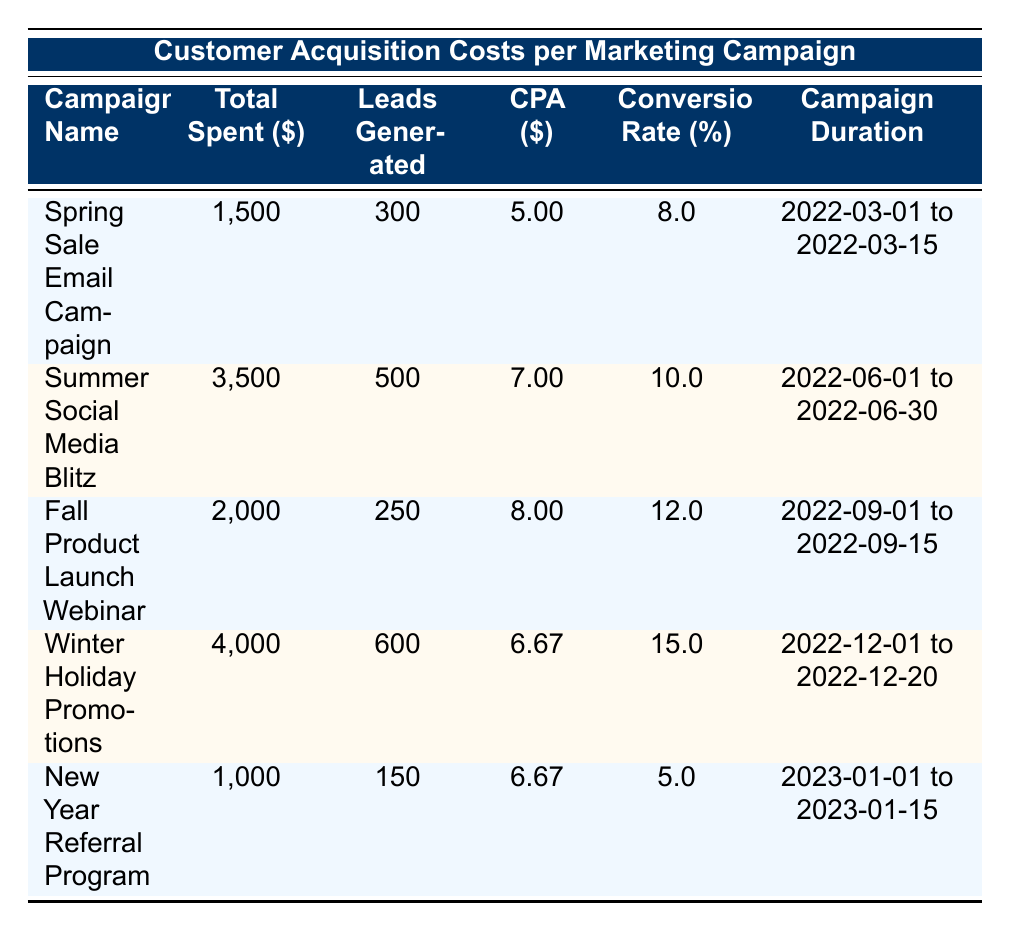What is the total amount spent on the Winter Holiday Promotions campaign? Referring to the table, the total spent for the Winter Holiday Promotions campaign is indicated in the second column under “Total Spent,” which shows $4000.
Answer: 4000 What is the conversion rate for the Summer Social Media Blitz campaign? Looking at the Summer Social Media Blitz campaign row, the conversion rate is listed in the fifth column as 10.0%.
Answer: 10.0 Which campaign had the lowest cost per acquisition? To determine the lowest cost per acquisition (CPA), I compare the CPA values from each row. The Spring Sale Email Campaign has the lowest CPA at $5.00.
Answer: 5.00 What is the total number of leads generated from all campaigns combined? I need to sum the leads generated from each campaign: 300 + 500 + 250 + 600 + 150 = 1800 leads in total.
Answer: 1800 Did the Fall Product Launch Webinar have a higher CPA than the New Year Referral Program? I check the CPA for both campaigns: the Fall Product Launch Webinar is $8.00, and the New Year Referral Program is $6.67. Since $8.00 is greater than $6.67, the statement is true.
Answer: Yes What was the average cost per acquisition across all campaigns? I sum the CPA values from each campaign: 5.00 + 7.00 + 8.00 + 6.67 + 6.67 = 33.34. Since there are 5 campaigns, the average CPA is 33.34 divided by 5, which is 6.668.
Answer: 6.668 Which campaign generated the most leads? I compare the leads generated across all campaigns. The Winter Holiday Promotions campaign generated 600 leads, which is the highest among all listed campaigns.
Answer: 600 Is the conversion rate of the New Year Referral Program higher than the Spring Sale Email Campaign? The New Year Referral Program has a conversion rate of 5.0%, and the Spring Sale Email Campaign has a conversion rate of 8.0%. Since 5.0% is less than 8.0%, the statement is false.
Answer: No How much total money was spent on the campaigns with a conversion rate above 10%? I check the conversion rates and find that the Winter Holiday Promotions and Fall Product Launch Webinar campaigns are the only ones above 10%. Their total spending is $4000 (Winter) + $2000 (Fall) = $6000.
Answer: 6000 